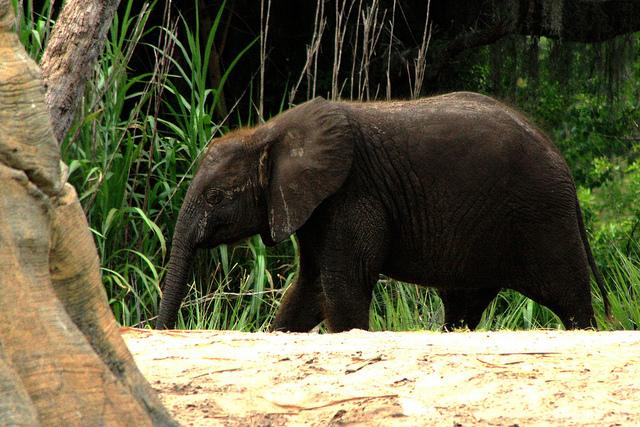What is the animal in front of the grass?
Quick response, please. Elephant. Is this a natural habitat?
Quick response, please. Yes. How big is this elephant?
Write a very short answer. Small. 